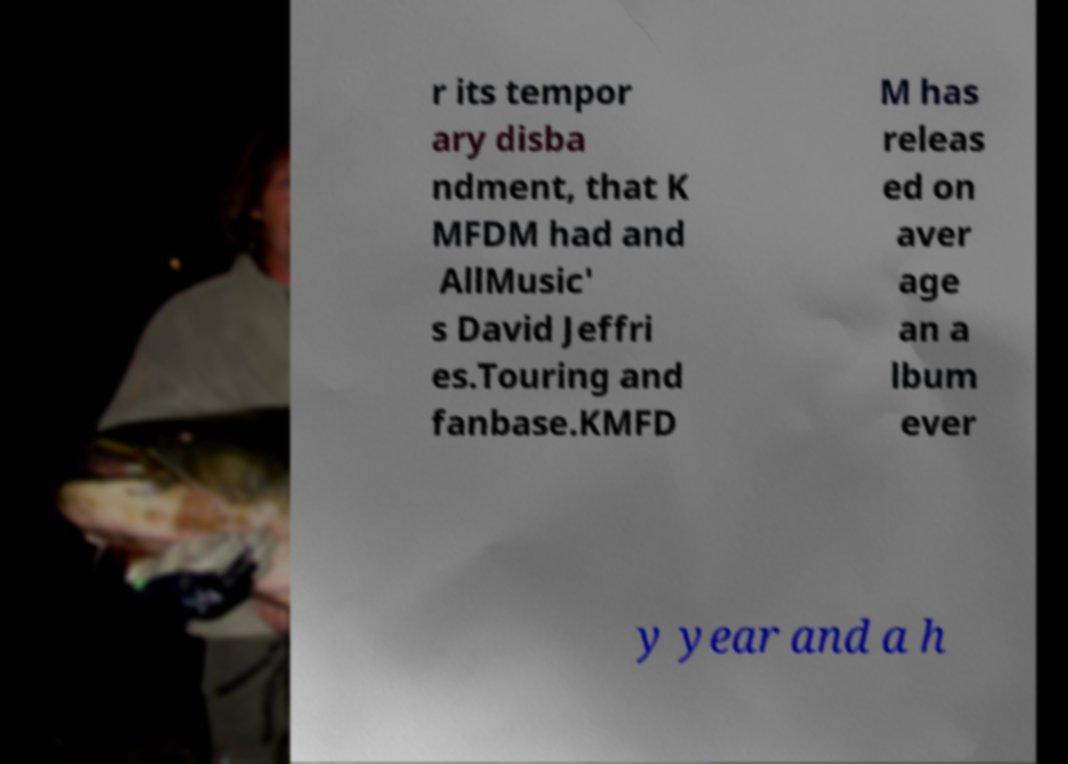There's text embedded in this image that I need extracted. Can you transcribe it verbatim? r its tempor ary disba ndment, that K MFDM had and AllMusic' s David Jeffri es.Touring and fanbase.KMFD M has releas ed on aver age an a lbum ever y year and a h 